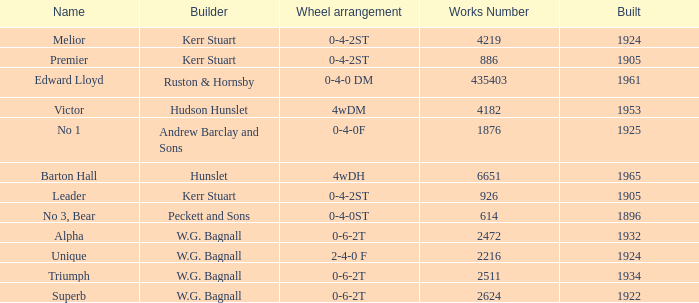What is the work number for Victor? 4182.0. 